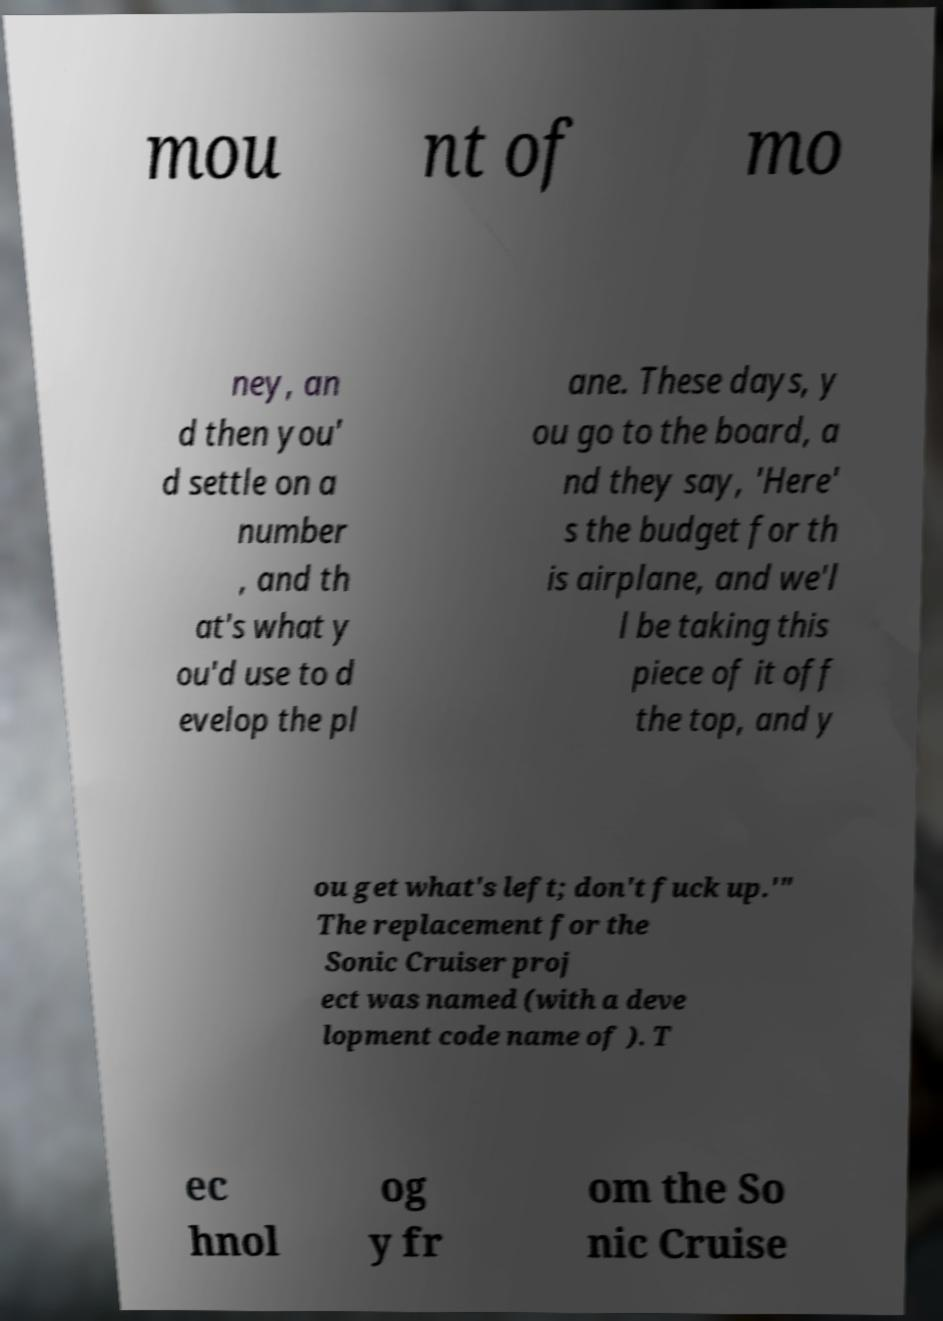Please identify and transcribe the text found in this image. mou nt of mo ney, an d then you' d settle on a number , and th at's what y ou'd use to d evelop the pl ane. These days, y ou go to the board, a nd they say, 'Here' s the budget for th is airplane, and we'l l be taking this piece of it off the top, and y ou get what's left; don't fuck up.'" The replacement for the Sonic Cruiser proj ect was named (with a deve lopment code name of ). T ec hnol og y fr om the So nic Cruise 